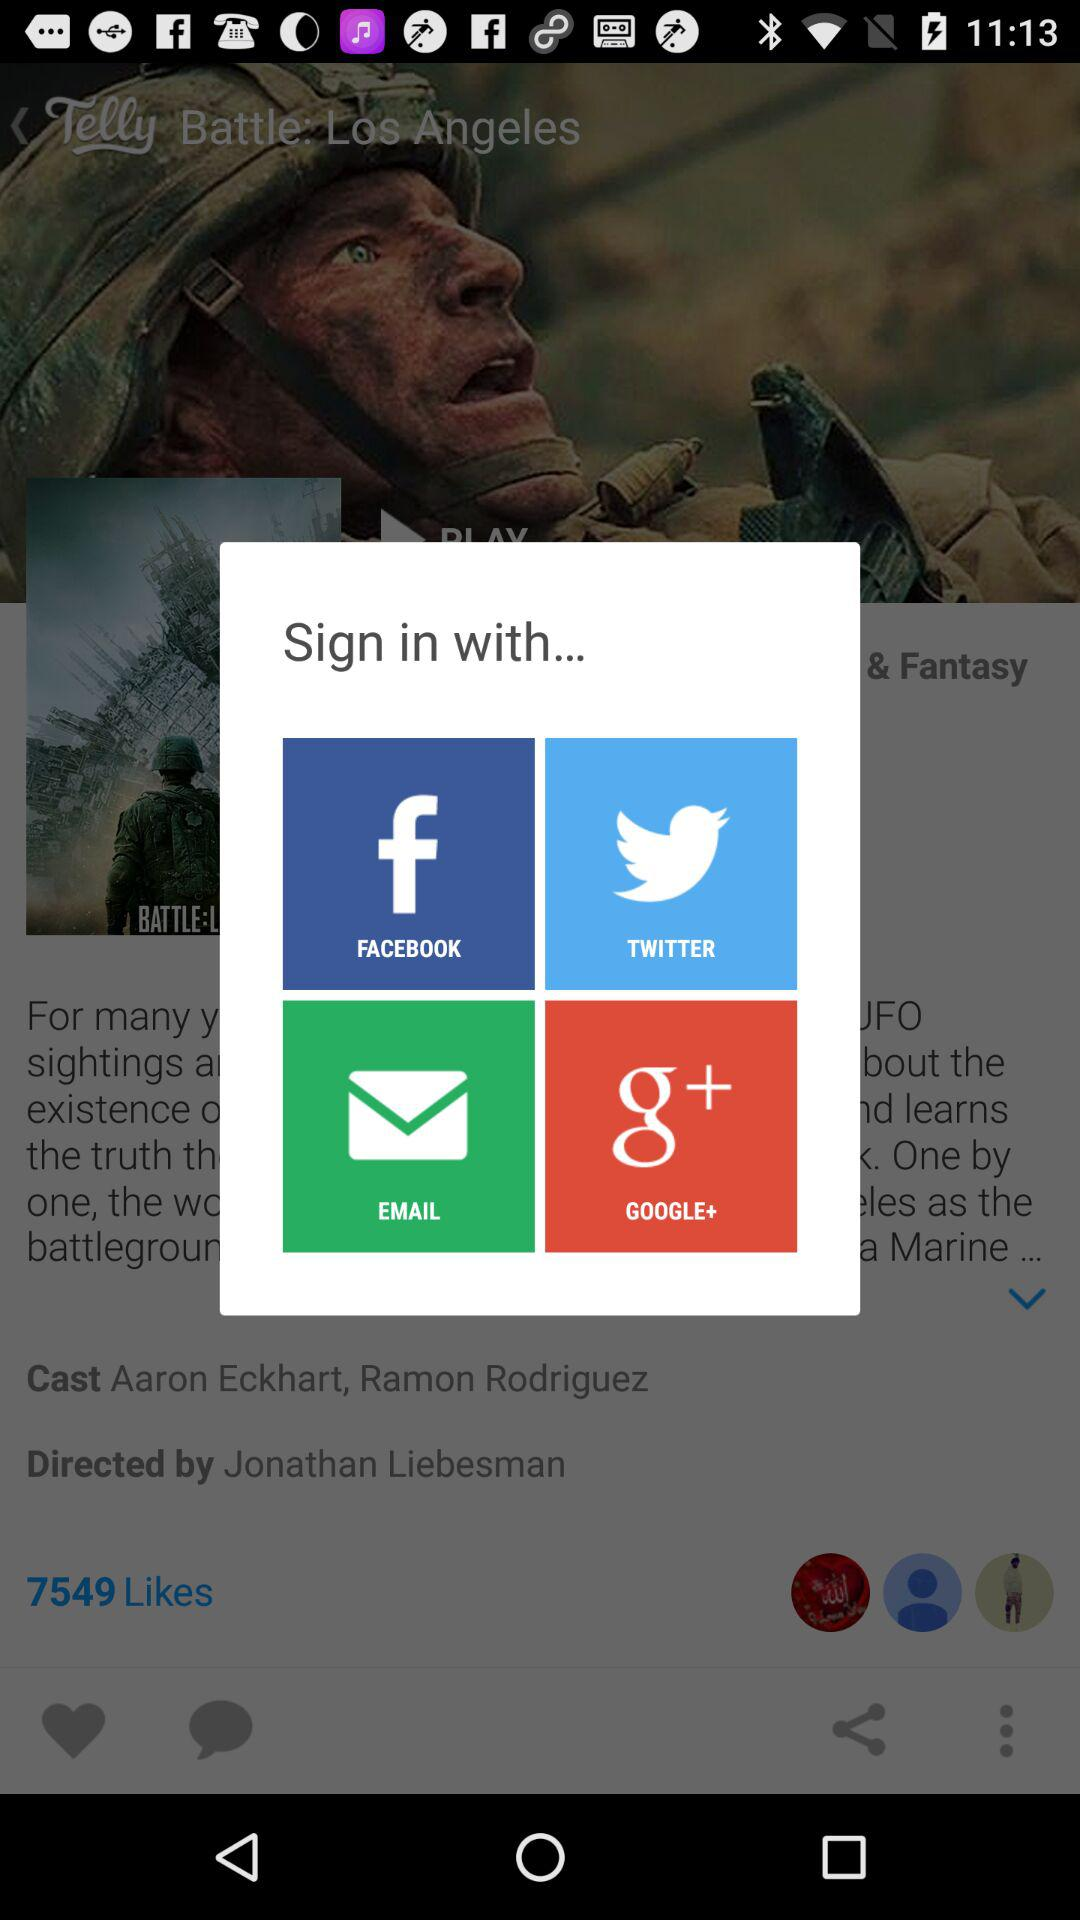What options are given for "Sign in with"? The options are "FACEBOOK", "TWITTER", "EMAIL" and "GOOGLE+". 